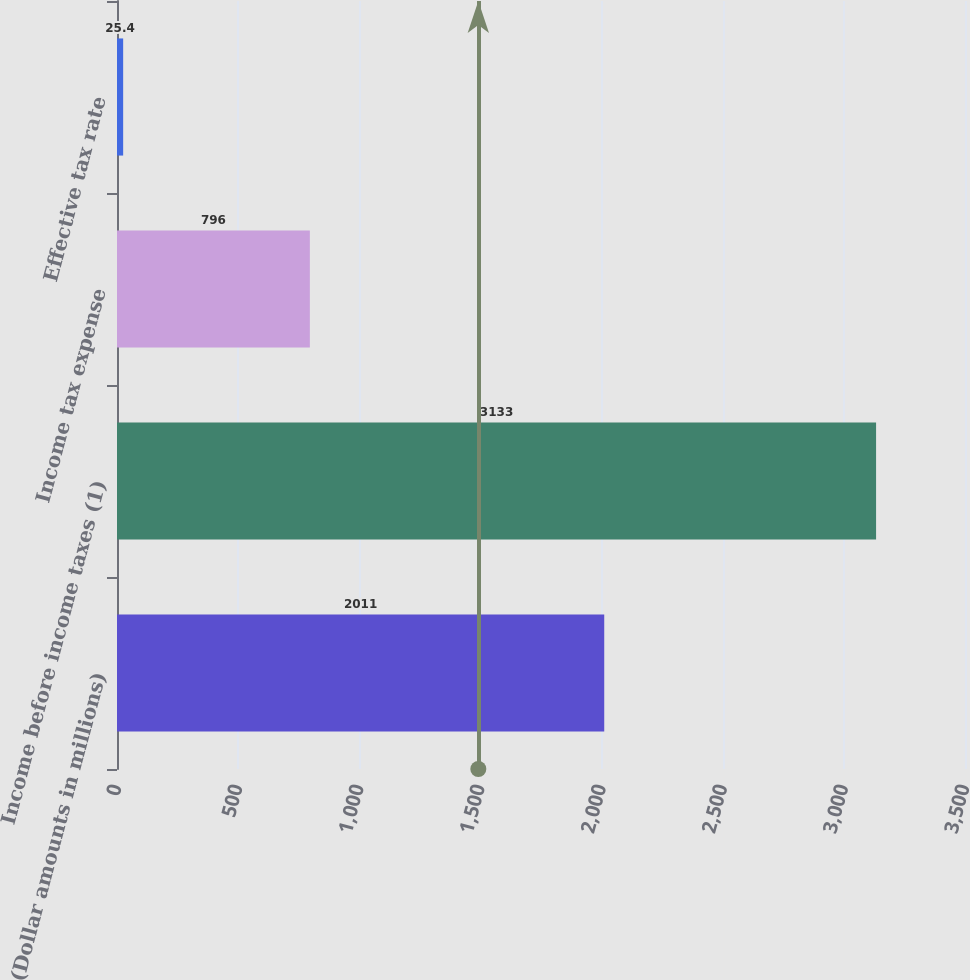<chart> <loc_0><loc_0><loc_500><loc_500><bar_chart><fcel>(Dollar amounts in millions)<fcel>Income before income taxes (1)<fcel>Income tax expense<fcel>Effective tax rate<nl><fcel>2011<fcel>3133<fcel>796<fcel>25.4<nl></chart> 